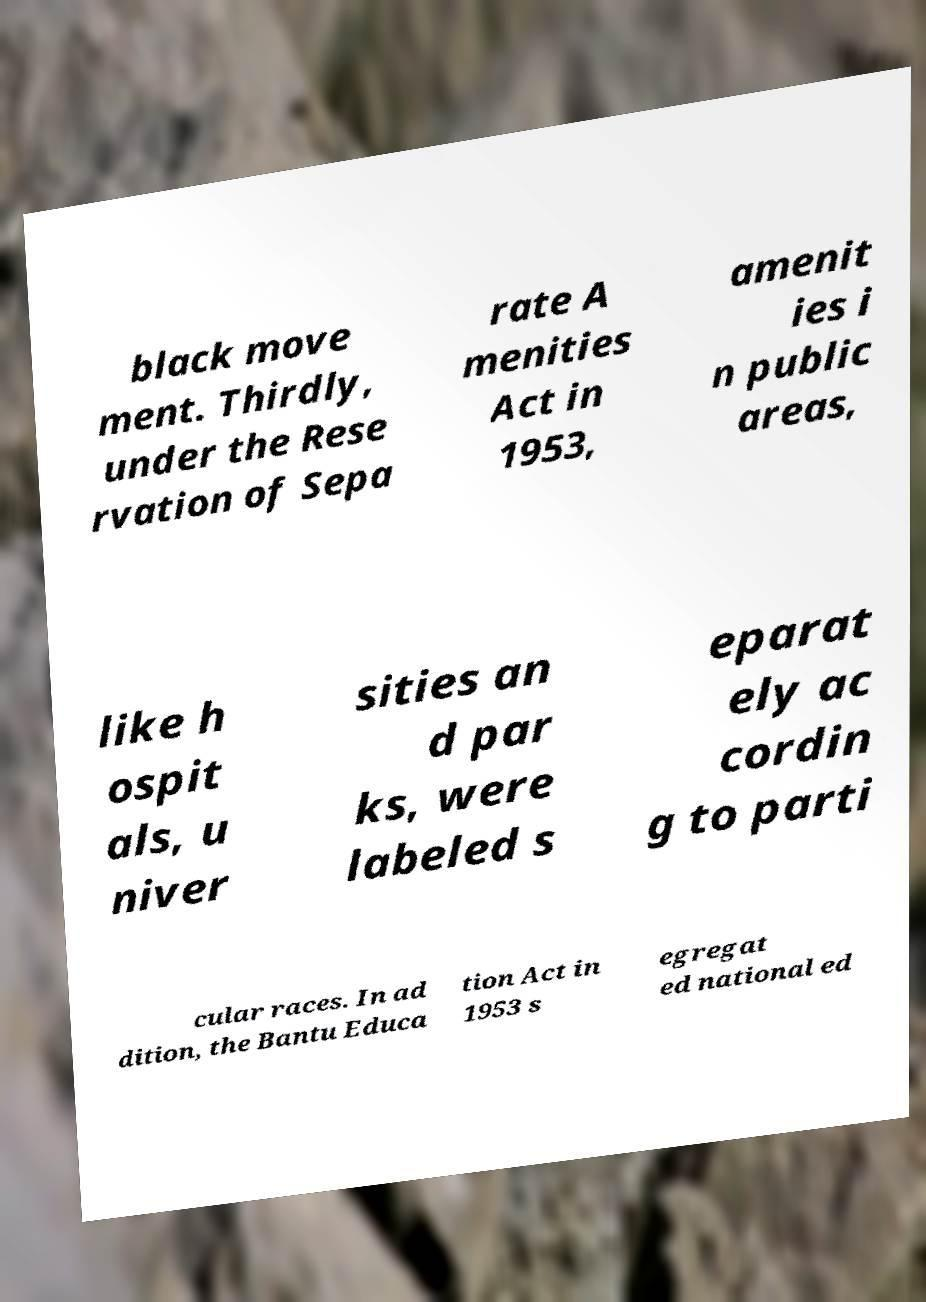Could you assist in decoding the text presented in this image and type it out clearly? black move ment. Thirdly, under the Rese rvation of Sepa rate A menities Act in 1953, amenit ies i n public areas, like h ospit als, u niver sities an d par ks, were labeled s eparat ely ac cordin g to parti cular races. In ad dition, the Bantu Educa tion Act in 1953 s egregat ed national ed 